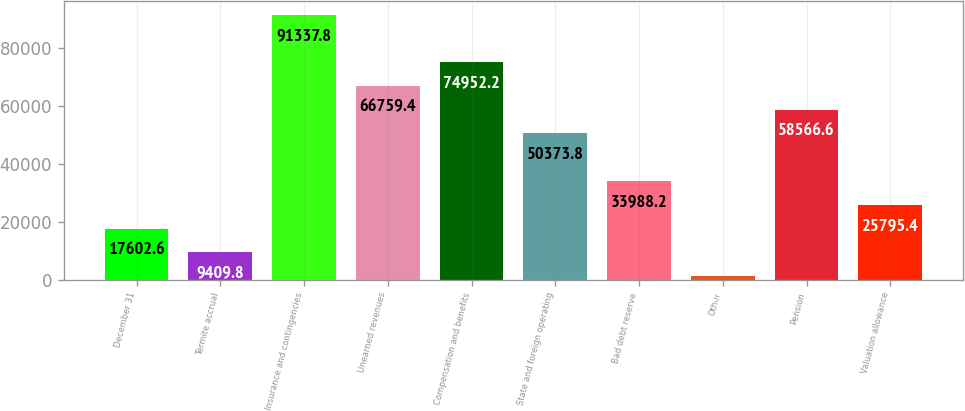Convert chart. <chart><loc_0><loc_0><loc_500><loc_500><bar_chart><fcel>December 31<fcel>Termite accrual<fcel>Insurance and contingencies<fcel>Unearned revenues<fcel>Compensation and benefits<fcel>State and foreign operating<fcel>Bad debt reserve<fcel>Other<fcel>Pension<fcel>Valuation allowance<nl><fcel>17602.6<fcel>9409.8<fcel>91337.8<fcel>66759.4<fcel>74952.2<fcel>50373.8<fcel>33988.2<fcel>1217<fcel>58566.6<fcel>25795.4<nl></chart> 